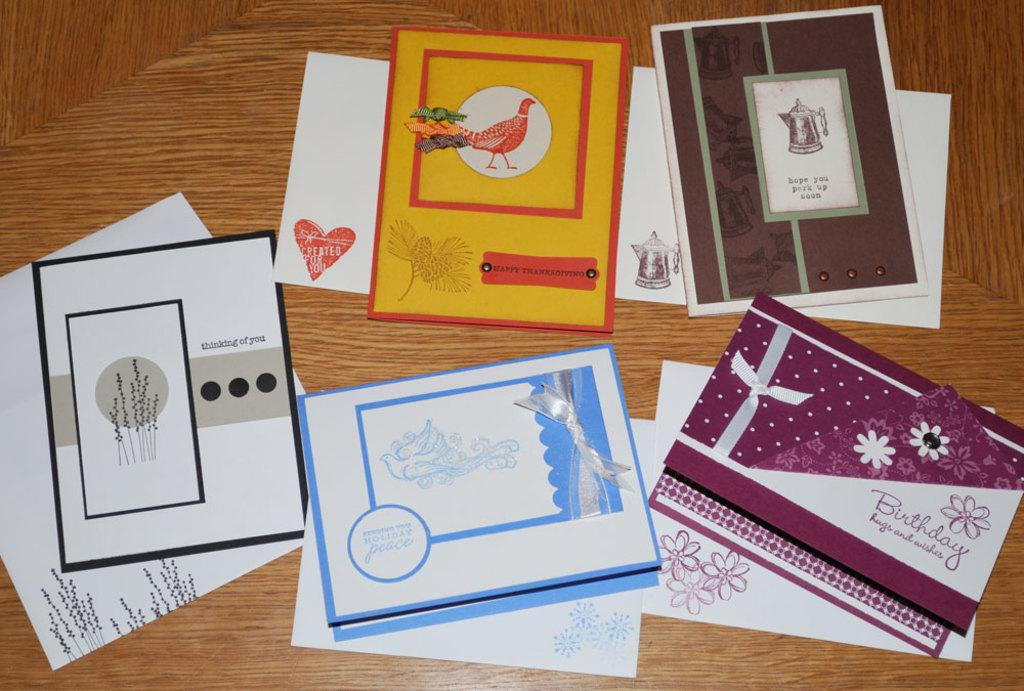<image>
Describe the image concisely. a series of books with one that says birthday 